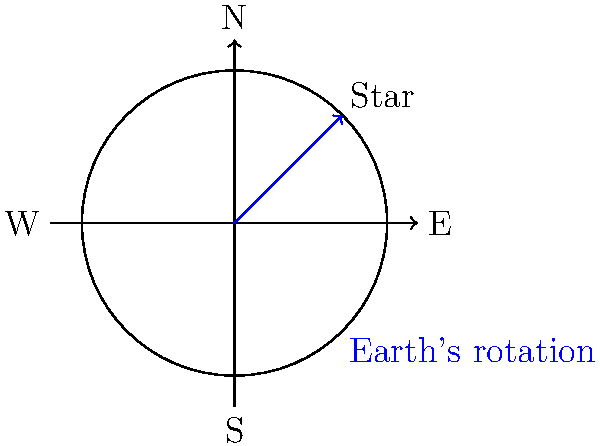As a politician advocating for dark sky preservation, you're explaining the concept of star movement to constituents. Using the diagram, which shows Earth's rotation and a star's apparent position, how would you describe the star's perceived motion over a 6-hour period? To explain the star's perceived motion over a 6-hour period, let's break it down step-by-step:

1. Earth's rotation: The Earth rotates on its axis once every 24 hours, moving from west to east.

2. Star's fixed position: In reality, the star's position in space remains relatively constant over short periods.

3. Observer's perspective: An observer on Earth sees the sky as if it were rotating around them.

4. Angular movement: In 24 hours, the sky appears to make a full 360° rotation. Therefore, in 6 hours, it would appear to rotate by:

   $\frac{6 \text{ hours}}{24 \text{ hours}} \times 360° = 90°$

5. Direction of movement: As Earth rotates eastward, stars appear to move westward in the sky.

6. Starting position: In the diagram, the star is initially in the northeast quadrant.

7. Final position: After 6 hours (90° rotation), the star would appear to move counterclockwise, ending up in the northwest quadrant.

This explanation demonstrates how Earth's rotation creates the illusion of stellar motion, emphasizing the importance of dark sky preservation for observing this natural phenomenon.
Answer: 90° counterclockwise, from northeast to northwest 